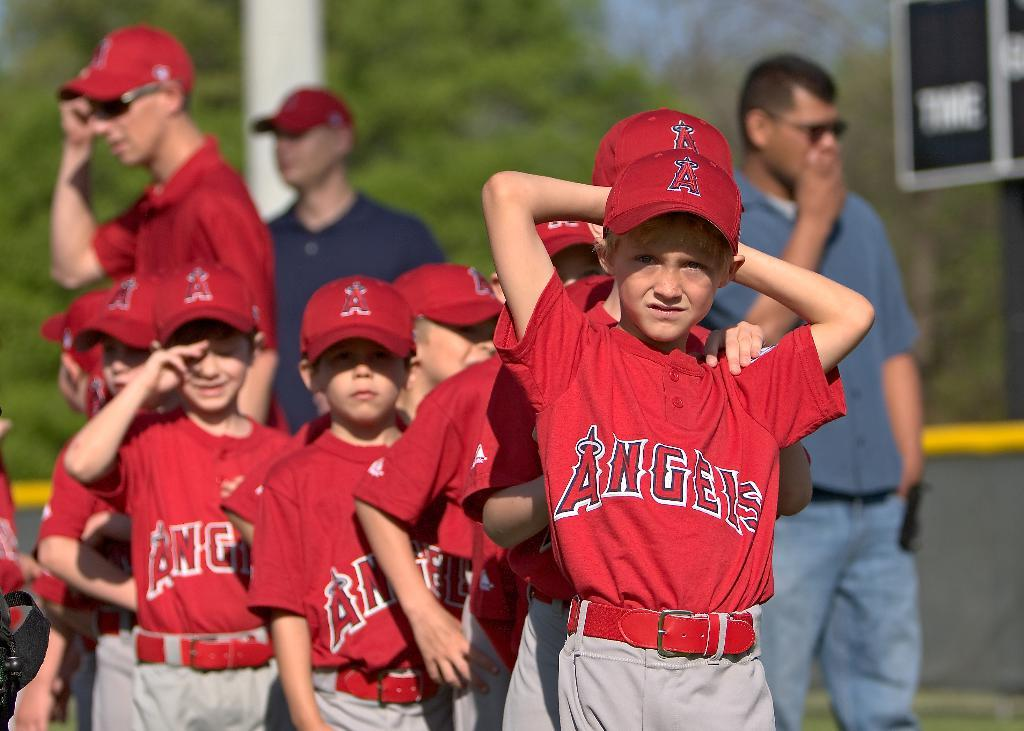<image>
Provide a brief description of the given image. Boys wearing red Angels jersey's stand in line near the coaches 